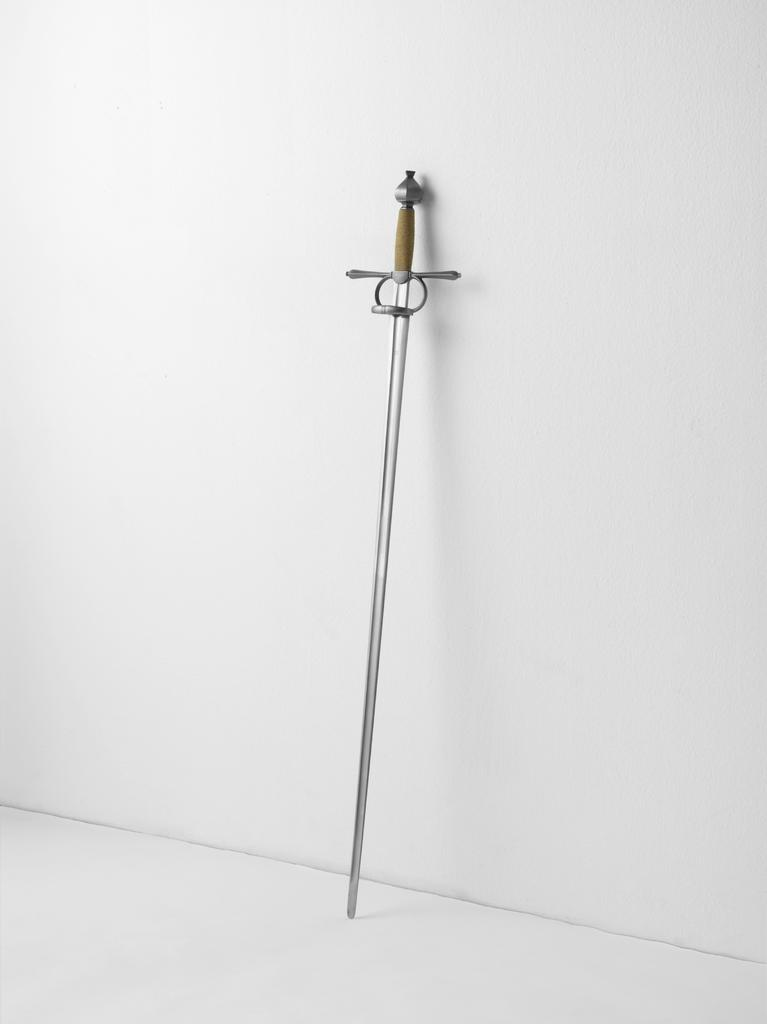What object is present in the image? There is a sword in the image. Where is the sword located in relation to other objects or structures? The sword is kept near a wall. What is the color of the wall? The wall is in white color. What type of pump can be seen in the image? There is no pump present in the image; it features a sword kept near a white wall. 